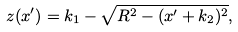Convert formula to latex. <formula><loc_0><loc_0><loc_500><loc_500>z ( x ^ { \prime } ) = k _ { 1 } - \sqrt { R ^ { 2 } - ( x ^ { \prime } + k _ { 2 } ) ^ { 2 } } ,</formula> 